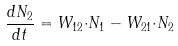Convert formula to latex. <formula><loc_0><loc_0><loc_500><loc_500>\frac { d N _ { 2 } } { d t } = W _ { 1 2 } { \cdot } N _ { 1 } - W _ { 2 1 } { \cdot } N _ { 2 }</formula> 